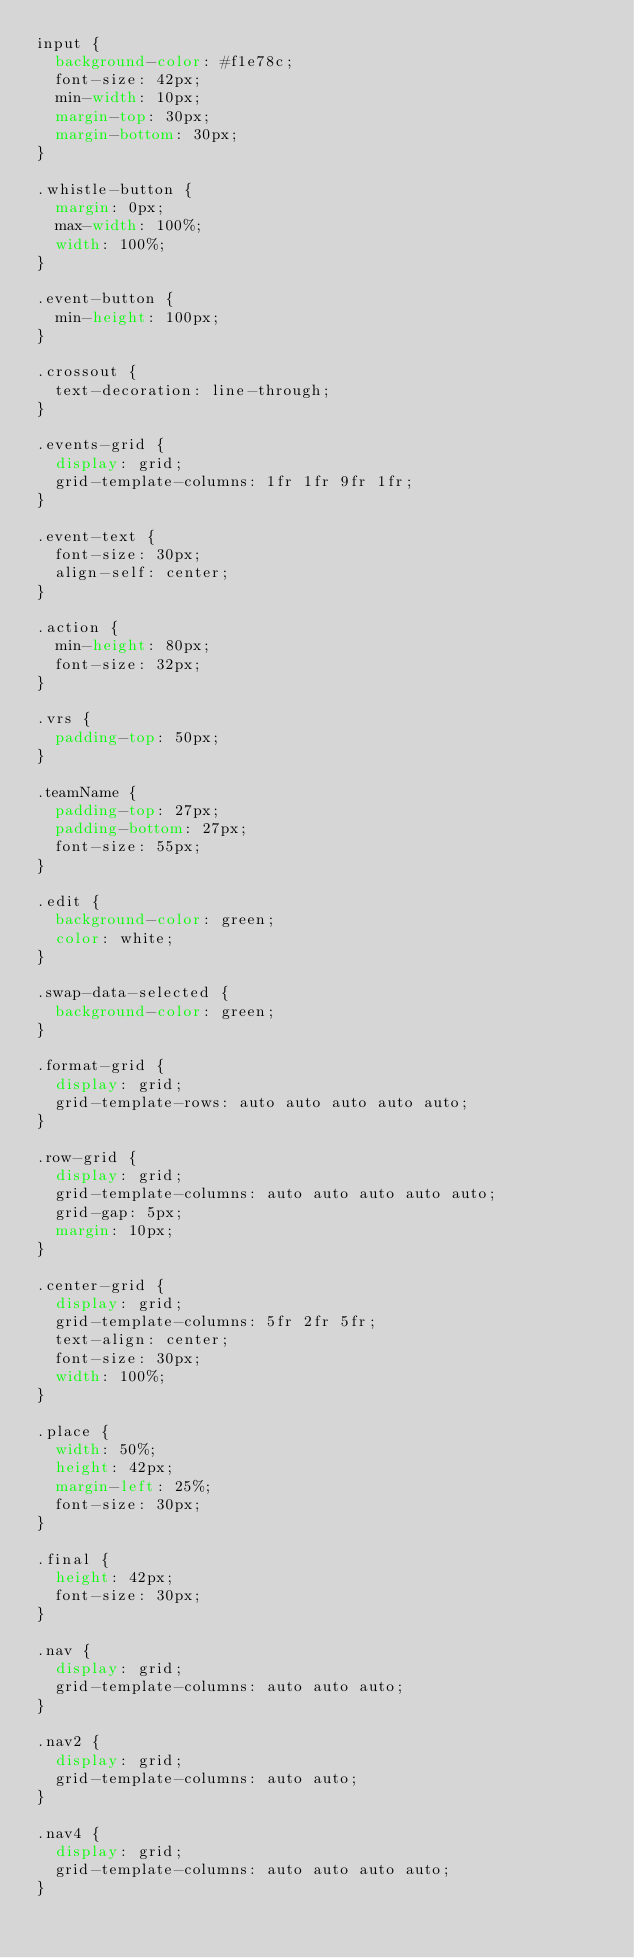<code> <loc_0><loc_0><loc_500><loc_500><_CSS_>input {
  background-color: #f1e78c;
  font-size: 42px;
  min-width: 10px;
  margin-top: 30px;
  margin-bottom: 30px;
}

.whistle-button {
  margin: 0px;
  max-width: 100%;
  width: 100%;
}

.event-button {
  min-height: 100px;
}

.crossout {
  text-decoration: line-through;
}

.events-grid {
  display: grid;
  grid-template-columns: 1fr 1fr 9fr 1fr;
}

.event-text {
  font-size: 30px;
  align-self: center;
}

.action {
  min-height: 80px;
  font-size: 32px;
}

.vrs {
  padding-top: 50px;
}

.teamName {
  padding-top: 27px;
  padding-bottom: 27px;
  font-size: 55px;
}

.edit {
  background-color: green;
  color: white;
}

.swap-data-selected {
  background-color: green;
}

.format-grid {
  display: grid;
  grid-template-rows: auto auto auto auto auto;
}

.row-grid {
  display: grid;
  grid-template-columns: auto auto auto auto auto;
  grid-gap: 5px;
  margin: 10px;
}

.center-grid {
  display: grid;
  grid-template-columns: 5fr 2fr 5fr;
  text-align: center;
  font-size: 30px;
  width: 100%;
}

.place {
  width: 50%;
  height: 42px;
  margin-left: 25%;
  font-size: 30px;
}

.final {
  height: 42px;
  font-size: 30px;
}

.nav {
  display: grid;
  grid-template-columns: auto auto auto;
}

.nav2 {
  display: grid;
  grid-template-columns: auto auto;
}

.nav4 {
  display: grid;
  grid-template-columns: auto auto auto auto;
}
</code> 